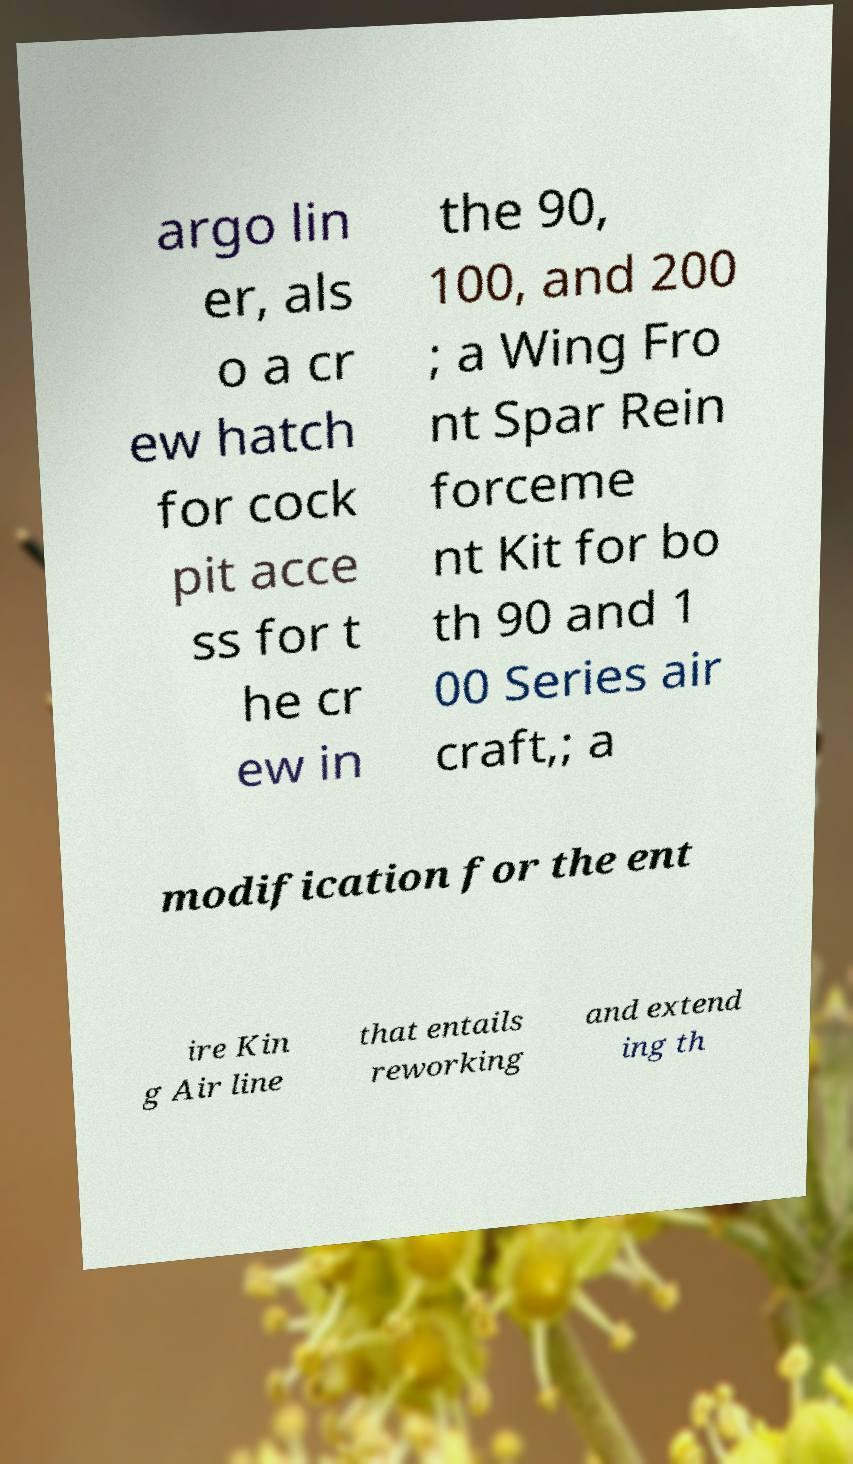For documentation purposes, I need the text within this image transcribed. Could you provide that? argo lin er, als o a cr ew hatch for cock pit acce ss for t he cr ew in the 90, 100, and 200 ; a Wing Fro nt Spar Rein forceme nt Kit for bo th 90 and 1 00 Series air craft,; a modification for the ent ire Kin g Air line that entails reworking and extend ing th 